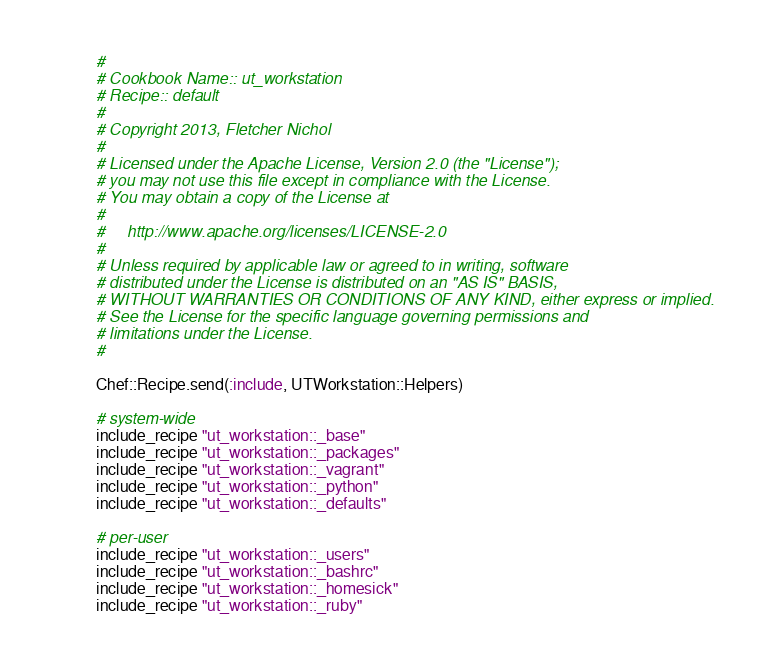<code> <loc_0><loc_0><loc_500><loc_500><_Ruby_>#
# Cookbook Name:: ut_workstation
# Recipe:: default
#
# Copyright 2013, Fletcher Nichol
#
# Licensed under the Apache License, Version 2.0 (the "License");
# you may not use this file except in compliance with the License.
# You may obtain a copy of the License at
#
#     http://www.apache.org/licenses/LICENSE-2.0
#
# Unless required by applicable law or agreed to in writing, software
# distributed under the License is distributed on an "AS IS" BASIS,
# WITHOUT WARRANTIES OR CONDITIONS OF ANY KIND, either express or implied.
# See the License for the specific language governing permissions and
# limitations under the License.
#

Chef::Recipe.send(:include, UTWorkstation::Helpers)

# system-wide
include_recipe "ut_workstation::_base"
include_recipe "ut_workstation::_packages"
include_recipe "ut_workstation::_vagrant"
include_recipe "ut_workstation::_python"
include_recipe "ut_workstation::_defaults"

# per-user
include_recipe "ut_workstation::_users"
include_recipe "ut_workstation::_bashrc"
include_recipe "ut_workstation::_homesick"
include_recipe "ut_workstation::_ruby"
</code> 